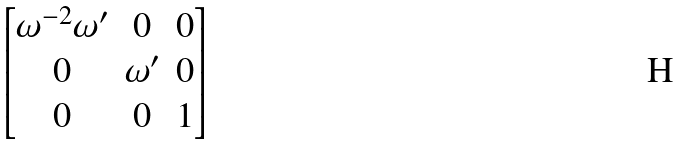Convert formula to latex. <formula><loc_0><loc_0><loc_500><loc_500>\begin{bmatrix} \omega ^ { - 2 } \omega ^ { \prime } & 0 & 0 \\ 0 & \omega ^ { \prime } & 0 \\ 0 & 0 & 1 \\ \end{bmatrix}</formula> 